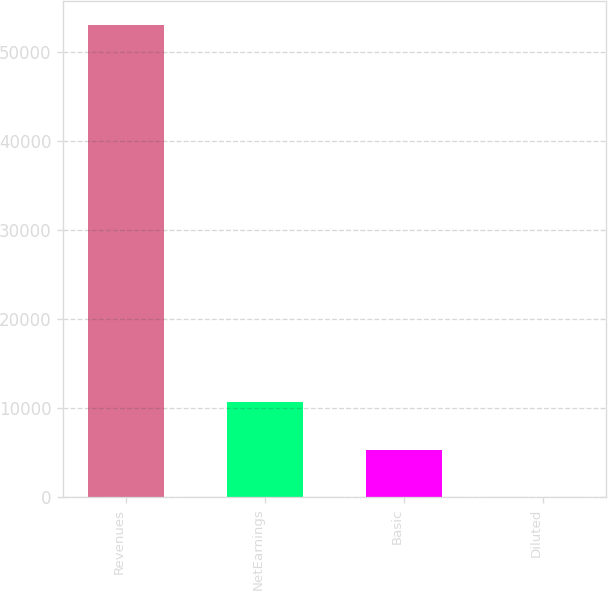<chart> <loc_0><loc_0><loc_500><loc_500><bar_chart><fcel>Revenues<fcel>NetEarnings<fcel>Basic<fcel>Diluted<nl><fcel>53051<fcel>10611.8<fcel>5306.92<fcel>2.02<nl></chart> 